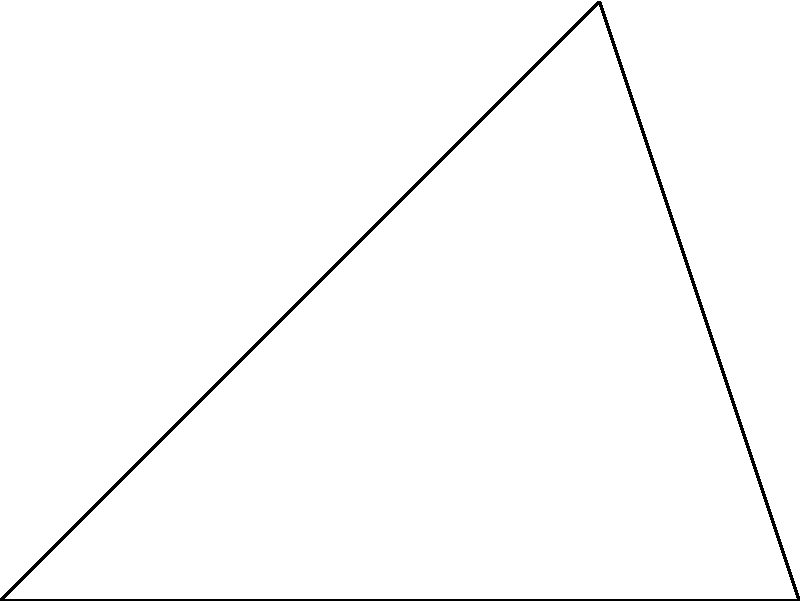As Marián Pišoja's teammate, you're practicing corner kicks. The goal post is located at point B, 5 meters away from the corner flag at O. If the optimal angle for the corner kick is 45°, what is the distance r (in meters) from the corner flag to the point where the ball should land for the most effective shot on goal? Use polar coordinates to solve this problem. Let's approach this step-by-step using polar coordinates:

1) In polar coordinates, a point is represented by its distance from the origin (r) and the angle ($\theta$) from the positive x-axis.

2) We're given that the optimal angle $\theta = 45°$.

3) We know that the goal post (point B) is 5 meters away from the corner flag (point O).

4) This forms a right-angled triangle OAB, where:
   - OA is along the sideline (x-axis)
   - AB is perpendicular to OA (y-axis)
   - OB is the hypotenuse, with length 5 meters

5) In a 45-45-90 triangle, the two legs are equal. So OA = AB.

6) Let's call the length of OA (and AB) x. Then by the Pythagorean theorem:

   $$x^2 + x^2 = 5^2$$
   $$2x^2 = 25$$
   $$x^2 = 12.5$$
   $$x = \sqrt{12.5} \approx 3.54$$

7) The distance r we're looking for is the same as OB, which is 5 meters.

Therefore, the optimal distance r for the corner kick is 5 meters.
Answer: 5 meters 